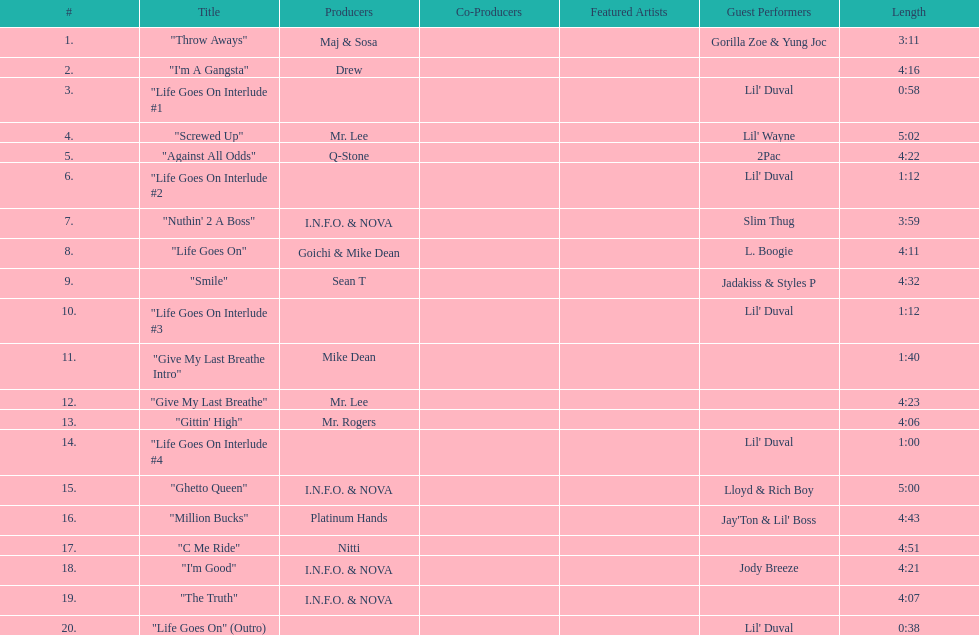What is the last track produced by mr. lee? "Give My Last Breathe". 